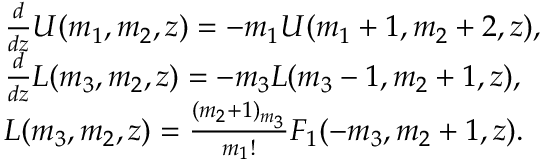Convert formula to latex. <formula><loc_0><loc_0><loc_500><loc_500>\begin{array} { r l } & { \frac { d } { d z } U ( m _ { 1 } , m _ { 2 } , z ) = - m _ { 1 } U ( m _ { 1 } + 1 , m _ { 2 } + 2 , z ) , } \\ & { \frac { d } { d z } L ( m _ { 3 } , m _ { 2 } , z ) = - m _ { 3 } L ( m _ { 3 } - 1 , m _ { 2 } + 1 , z ) , } \\ & { L ( m _ { 3 } , m _ { 2 } , z ) = \frac { ( m _ { 2 } + 1 ) _ { m _ { 3 } } } { m _ { 1 } ! } F _ { 1 } ( - m _ { 3 } , m _ { 2 } + 1 , z ) . } \end{array}</formula> 